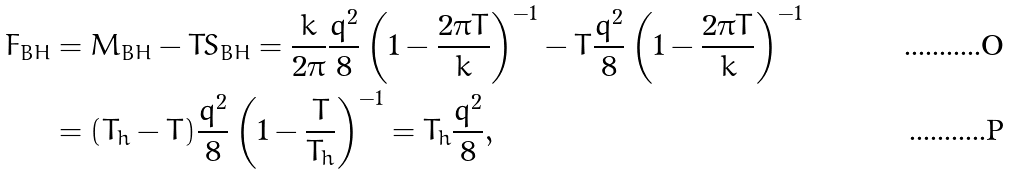<formula> <loc_0><loc_0><loc_500><loc_500>F _ { B H } & = M _ { B H } - T S _ { B H } = \frac { k } { 2 \pi } \frac { q ^ { 2 } } { 8 } \left ( 1 - \frac { 2 \pi T } { k } \right ) ^ { - 1 } - T \frac { q ^ { 2 } } { 8 } \left ( 1 - \frac { 2 \pi T } { k } \right ) ^ { - 1 } \\ & = ( T _ { h } - T ) \frac { q ^ { 2 } } { 8 } \left ( 1 - \frac { T } { T _ { h } } \right ) ^ { - 1 } = T _ { h } \frac { q ^ { 2 } } { 8 } ,</formula> 